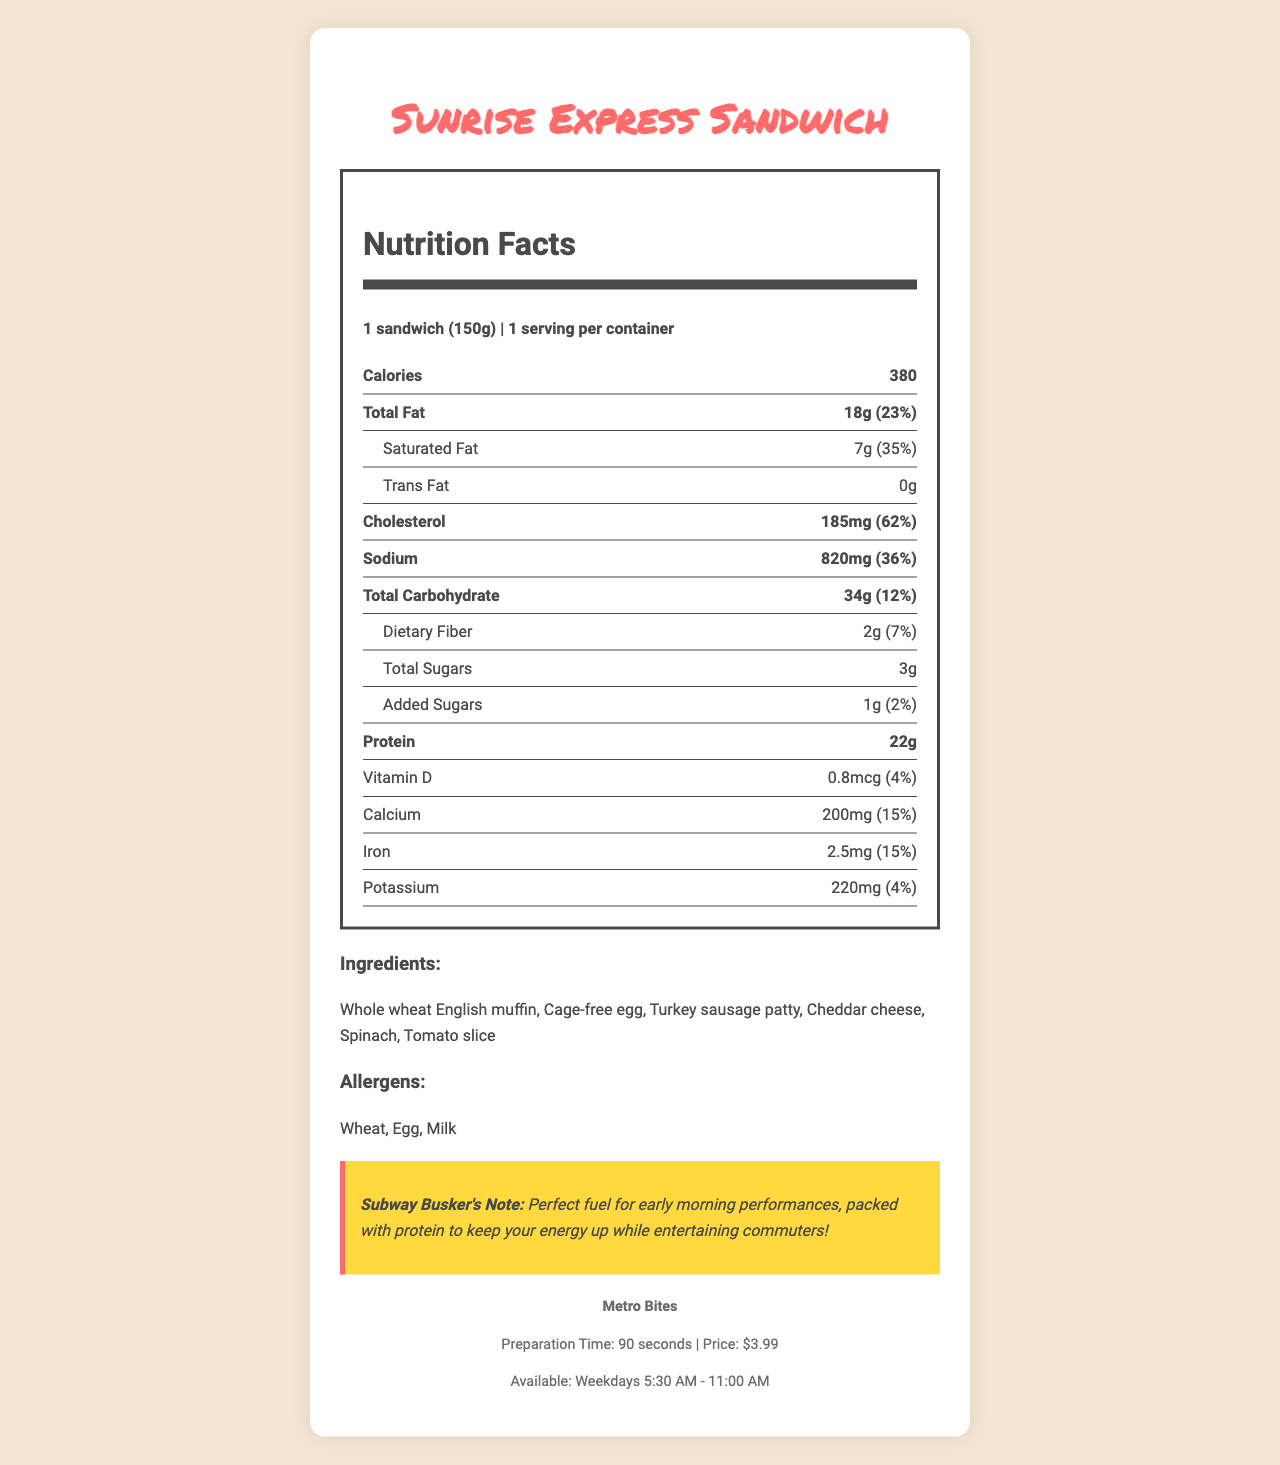what is the product name? The product name is highlighted in the title of the document as "Sunrise Express Sandwich".
Answer: Sunrise Express Sandwich what is the serving size for the Sunrise Express Sandwich? According to the nutrition facts label, the serving size is listed as "1 sandwich (150g)".
Answer: 1 sandwich (150g) how many calories are in one sandwich? The document specifies that one sandwich contains 380 calories.
Answer: 380 calories what are the main ingredients of the sandwich? The ingredients are listed in the section labeled "Ingredients".
Answer: Whole wheat English muffin, Cage-free egg, Turkey sausage patty, Cheddar cheese, Spinach, Tomato slice what allergens does the sandwich contain? The allergens are listed in the section titled "Allergens".
Answer: Wheat, Egg, Milk how much protein is in the sandwich? The nutrition facts label shows that the sandwich has 22g of protein.
Answer: 22g what is the cholesterol content and its daily value percentage? The document states there is 185mg of cholesterol, which is 62% of the daily value.
Answer: 185mg, 62% how much sodium is in the sandwich? The nutrition facts label states the sandwich contains 820mg of sodium.
Answer: 820mg what percentage of the daily value is the total fat content? The document shows that the total fat content percentage of the daily value is 23%.
Answer: 23% which nutrient has the highest daily value percentage? A. Protein B. Sodium C. Cholesterol According to the document, cholesterol has the highest daily value percentage at 62%.
Answer: C. Cholesterol what is the serving per container? A. 1 B. 2 C. 3 The document specifies that there is 1 serving per container.
Answer: A. 1 is the sandwich free of trans fat? The nutrition facts label indicates that the sandwich contains 0g of trans fat.
Answer: Yes does the sandwich have more calories or carbohydrates? The sandwich has 380 calories and 34g of total carbohydrate, which means it has more calories.
Answer: Calories describe the main points from the document. The explanation highlights the most important details of the sandwich, including its nutritional information, ingredients, allergens, availability, preparation time, and price.
Answer: The Sunrise Express Sandwich is a breakfast item from Metro Bites, containing 380 calories and various nutrients. It has 22g of protein and is made from ingredients like whole wheat English muffin, cage-free egg, turkey sausage patty, cheddar cheese, spinach, and a tomato slice. It contains allergens such as wheat, egg, and milk. It's available on weekdays from 5:30 AM to 11:00 AM, with a preparation time of 90 seconds and a price of $3.99. at what time is the sandwich available at the restaurant? The document states the sandwich is available on weekdays from 5:30 AM to 11:00 AM.
Answer: Weekdays 5:30 AM - 11:00 AM what is the restaurant chain that offers this sandwich? The document lists "Metro Bites" as the restaurant chain offering the sandwich.
Answer: Metro Bites how much vitamin d is in the sandwich? The nutrition facts label specifies that the sandwich contains 0.8mcg of vitamin D.
Answer: 0.8mcg is it possible to determine how many sandwiches a person needs to eat to fulfill 100% of their daily cholesterol intake? The document does not specify the total daily amount of cholesterol or how many sandwiches would be needed to reach 100% of the daily value beyond the provided percentage for one sandwich.
Answer: No how much calcium does the sandwich provide in terms of the daily value percentage? The document shows that the sandwich provides 15% of the daily value for calcium.
Answer: 15% 